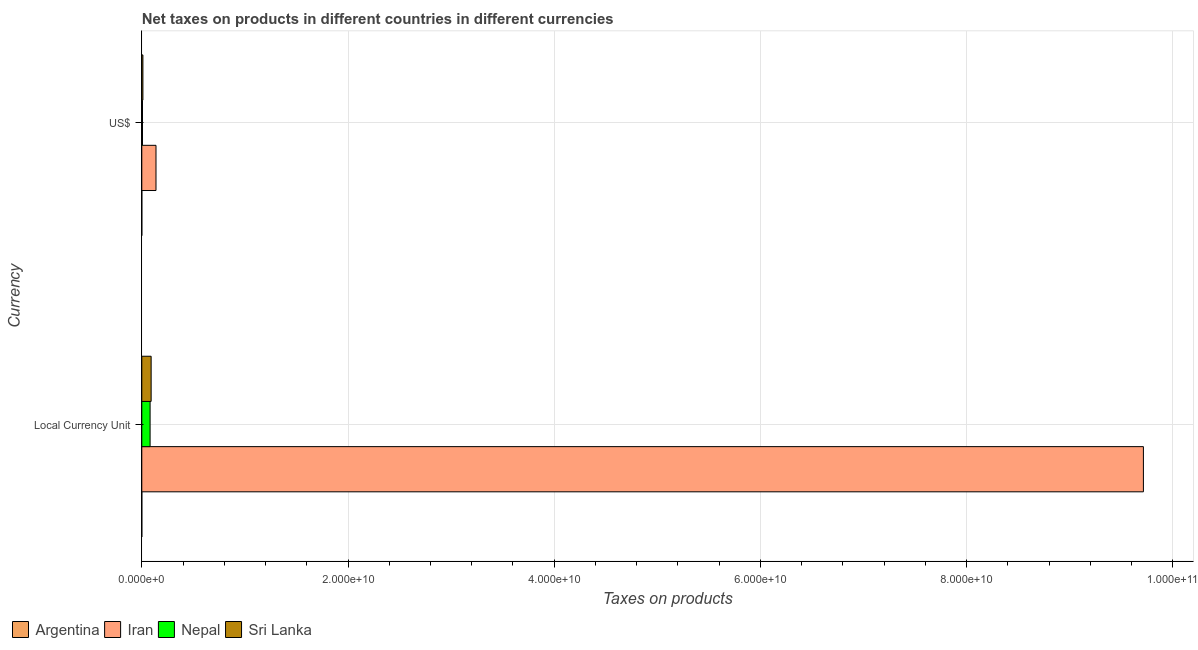How many different coloured bars are there?
Your answer should be very brief. 4. How many groups of bars are there?
Keep it short and to the point. 2. Are the number of bars on each tick of the Y-axis equal?
Ensure brevity in your answer.  Yes. How many bars are there on the 1st tick from the top?
Offer a terse response. 4. How many bars are there on the 2nd tick from the bottom?
Provide a short and direct response. 4. What is the label of the 2nd group of bars from the top?
Keep it short and to the point. Local Currency Unit. What is the net taxes in constant 2005 us$ in Argentina?
Your response must be concise. 8.36849e-5. Across all countries, what is the maximum net taxes in constant 2005 us$?
Give a very brief answer. 9.72e+1. Across all countries, what is the minimum net taxes in us$?
Keep it short and to the point. 4.18e+04. In which country was the net taxes in constant 2005 us$ maximum?
Your answer should be very brief. Iran. In which country was the net taxes in constant 2005 us$ minimum?
Your response must be concise. Argentina. What is the total net taxes in constant 2005 us$ in the graph?
Offer a terse response. 9.89e+1. What is the difference between the net taxes in constant 2005 us$ in Sri Lanka and that in Nepal?
Offer a very short reply. 1.01e+08. What is the difference between the net taxes in us$ in Sri Lanka and the net taxes in constant 2005 us$ in Argentina?
Offer a terse response. 1.08e+08. What is the average net taxes in constant 2005 us$ per country?
Provide a short and direct response. 2.47e+1. What is the difference between the net taxes in us$ and net taxes in constant 2005 us$ in Sri Lanka?
Your response must be concise. -7.98e+08. In how many countries, is the net taxes in us$ greater than 56000000000 units?
Your answer should be very brief. 0. What is the ratio of the net taxes in us$ in Nepal to that in Iran?
Provide a succinct answer. 0.05. Is the net taxes in constant 2005 us$ in Nepal less than that in Sri Lanka?
Keep it short and to the point. Yes. In how many countries, is the net taxes in us$ greater than the average net taxes in us$ taken over all countries?
Offer a very short reply. 1. What does the 2nd bar from the top in US$ represents?
Provide a short and direct response. Nepal. What does the 4th bar from the bottom in US$ represents?
Provide a succinct answer. Sri Lanka. How many bars are there?
Your answer should be very brief. 8. Are all the bars in the graph horizontal?
Offer a terse response. Yes. Are the values on the major ticks of X-axis written in scientific E-notation?
Your answer should be very brief. Yes. Does the graph contain any zero values?
Ensure brevity in your answer.  No. How many legend labels are there?
Keep it short and to the point. 4. How are the legend labels stacked?
Provide a succinct answer. Horizontal. What is the title of the graph?
Give a very brief answer. Net taxes on products in different countries in different currencies. Does "Latvia" appear as one of the legend labels in the graph?
Keep it short and to the point. No. What is the label or title of the X-axis?
Your answer should be very brief. Taxes on products. What is the label or title of the Y-axis?
Your answer should be very brief. Currency. What is the Taxes on products in Argentina in Local Currency Unit?
Your answer should be compact. 8.36849e-5. What is the Taxes on products of Iran in Local Currency Unit?
Provide a succinct answer. 9.72e+1. What is the Taxes on products in Nepal in Local Currency Unit?
Ensure brevity in your answer.  8.05e+08. What is the Taxes on products in Sri Lanka in Local Currency Unit?
Your answer should be very brief. 9.06e+08. What is the Taxes on products in Argentina in US$?
Ensure brevity in your answer.  4.18e+04. What is the Taxes on products in Iran in US$?
Ensure brevity in your answer.  1.38e+09. What is the Taxes on products of Nepal in US$?
Give a very brief answer. 6.72e+07. What is the Taxes on products in Sri Lanka in US$?
Offer a terse response. 1.08e+08. Across all Currency, what is the maximum Taxes on products of Argentina?
Your answer should be very brief. 4.18e+04. Across all Currency, what is the maximum Taxes on products in Iran?
Your answer should be very brief. 9.72e+1. Across all Currency, what is the maximum Taxes on products in Nepal?
Provide a short and direct response. 8.05e+08. Across all Currency, what is the maximum Taxes on products in Sri Lanka?
Make the answer very short. 9.06e+08. Across all Currency, what is the minimum Taxes on products of Argentina?
Offer a very short reply. 8.36849e-5. Across all Currency, what is the minimum Taxes on products in Iran?
Offer a very short reply. 1.38e+09. Across all Currency, what is the minimum Taxes on products in Nepal?
Your answer should be compact. 6.72e+07. Across all Currency, what is the minimum Taxes on products of Sri Lanka?
Provide a short and direct response. 1.08e+08. What is the total Taxes on products of Argentina in the graph?
Your response must be concise. 4.18e+04. What is the total Taxes on products in Iran in the graph?
Make the answer very short. 9.85e+1. What is the total Taxes on products in Nepal in the graph?
Offer a very short reply. 8.72e+08. What is the total Taxes on products of Sri Lanka in the graph?
Provide a succinct answer. 1.01e+09. What is the difference between the Taxes on products of Argentina in Local Currency Unit and that in US$?
Your answer should be very brief. -4.18e+04. What is the difference between the Taxes on products of Iran in Local Currency Unit and that in US$?
Offer a very short reply. 9.58e+1. What is the difference between the Taxes on products in Nepal in Local Currency Unit and that in US$?
Offer a very short reply. 7.38e+08. What is the difference between the Taxes on products of Sri Lanka in Local Currency Unit and that in US$?
Provide a short and direct response. 7.98e+08. What is the difference between the Taxes on products of Argentina in Local Currency Unit and the Taxes on products of Iran in US$?
Your response must be concise. -1.38e+09. What is the difference between the Taxes on products of Argentina in Local Currency Unit and the Taxes on products of Nepal in US$?
Offer a terse response. -6.72e+07. What is the difference between the Taxes on products in Argentina in Local Currency Unit and the Taxes on products in Sri Lanka in US$?
Your answer should be very brief. -1.08e+08. What is the difference between the Taxes on products in Iran in Local Currency Unit and the Taxes on products in Nepal in US$?
Keep it short and to the point. 9.71e+1. What is the difference between the Taxes on products of Iran in Local Currency Unit and the Taxes on products of Sri Lanka in US$?
Give a very brief answer. 9.70e+1. What is the difference between the Taxes on products of Nepal in Local Currency Unit and the Taxes on products of Sri Lanka in US$?
Offer a very short reply. 6.97e+08. What is the average Taxes on products in Argentina per Currency?
Provide a short and direct response. 2.09e+04. What is the average Taxes on products in Iran per Currency?
Ensure brevity in your answer.  4.93e+1. What is the average Taxes on products of Nepal per Currency?
Give a very brief answer. 4.36e+08. What is the average Taxes on products of Sri Lanka per Currency?
Your answer should be compact. 5.07e+08. What is the difference between the Taxes on products of Argentina and Taxes on products of Iran in Local Currency Unit?
Keep it short and to the point. -9.72e+1. What is the difference between the Taxes on products in Argentina and Taxes on products in Nepal in Local Currency Unit?
Give a very brief answer. -8.05e+08. What is the difference between the Taxes on products of Argentina and Taxes on products of Sri Lanka in Local Currency Unit?
Your response must be concise. -9.06e+08. What is the difference between the Taxes on products in Iran and Taxes on products in Nepal in Local Currency Unit?
Make the answer very short. 9.63e+1. What is the difference between the Taxes on products in Iran and Taxes on products in Sri Lanka in Local Currency Unit?
Provide a short and direct response. 9.62e+1. What is the difference between the Taxes on products in Nepal and Taxes on products in Sri Lanka in Local Currency Unit?
Provide a short and direct response. -1.01e+08. What is the difference between the Taxes on products of Argentina and Taxes on products of Iran in US$?
Your answer should be very brief. -1.38e+09. What is the difference between the Taxes on products of Argentina and Taxes on products of Nepal in US$?
Your response must be concise. -6.72e+07. What is the difference between the Taxes on products in Argentina and Taxes on products in Sri Lanka in US$?
Offer a terse response. -1.08e+08. What is the difference between the Taxes on products in Iran and Taxes on products in Nepal in US$?
Offer a very short reply. 1.31e+09. What is the difference between the Taxes on products in Iran and Taxes on products in Sri Lanka in US$?
Provide a succinct answer. 1.27e+09. What is the difference between the Taxes on products in Nepal and Taxes on products in Sri Lanka in US$?
Give a very brief answer. -4.05e+07. What is the ratio of the Taxes on products of Argentina in Local Currency Unit to that in US$?
Ensure brevity in your answer.  0. What is the ratio of the Taxes on products in Iran in Local Currency Unit to that in US$?
Your answer should be compact. 70.53. What is the ratio of the Taxes on products of Nepal in Local Currency Unit to that in US$?
Offer a very short reply. 11.97. What is the ratio of the Taxes on products in Sri Lanka in Local Currency Unit to that in US$?
Offer a very short reply. 8.41. What is the difference between the highest and the second highest Taxes on products of Argentina?
Give a very brief answer. 4.18e+04. What is the difference between the highest and the second highest Taxes on products of Iran?
Your answer should be compact. 9.58e+1. What is the difference between the highest and the second highest Taxes on products in Nepal?
Your response must be concise. 7.38e+08. What is the difference between the highest and the second highest Taxes on products of Sri Lanka?
Ensure brevity in your answer.  7.98e+08. What is the difference between the highest and the lowest Taxes on products of Argentina?
Give a very brief answer. 4.18e+04. What is the difference between the highest and the lowest Taxes on products of Iran?
Your answer should be compact. 9.58e+1. What is the difference between the highest and the lowest Taxes on products in Nepal?
Make the answer very short. 7.38e+08. What is the difference between the highest and the lowest Taxes on products in Sri Lanka?
Make the answer very short. 7.98e+08. 